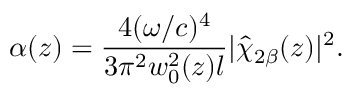Convert formula to latex. <formula><loc_0><loc_0><loc_500><loc_500>\alpha ( z ) = \frac { 4 ( \omega / c ) ^ { 4 } } { 3 \pi ^ { 2 } w _ { 0 } ^ { 2 } ( z ) l } | \hat { \chi } _ { 2 \beta } ( z ) | ^ { 2 } .</formula> 